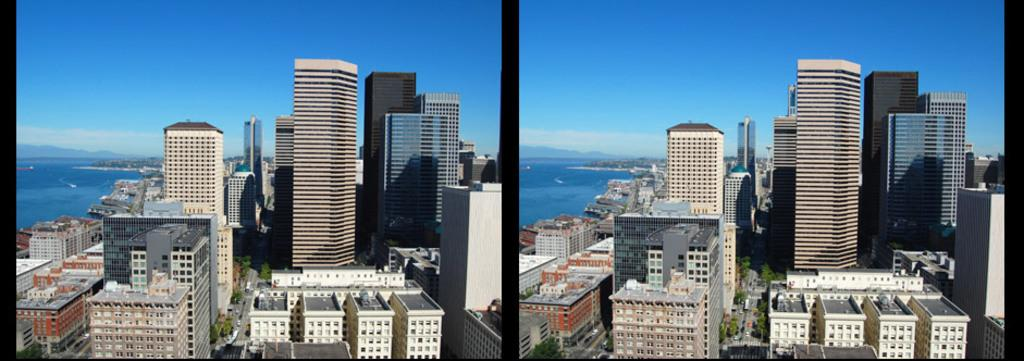How many images are combined in the collage? The image is a collage of 2 images. What can be seen in the images? There are many buildings in the images. What is present on the left side of the collage? There is water on the left side of the collage. What type of fruit is floating in the water on the left side of the collage? There is no fruit present in the image, as it only features a collage of 2 images with many buildings and water on the left side. 